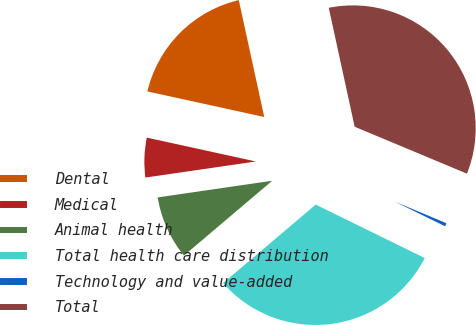<chart> <loc_0><loc_0><loc_500><loc_500><pie_chart><fcel>Dental<fcel>Medical<fcel>Animal health<fcel>Total health care distribution<fcel>Technology and value-added<fcel>Total<nl><fcel>18.16%<fcel>5.73%<fcel>8.89%<fcel>31.55%<fcel>0.96%<fcel>34.71%<nl></chart> 